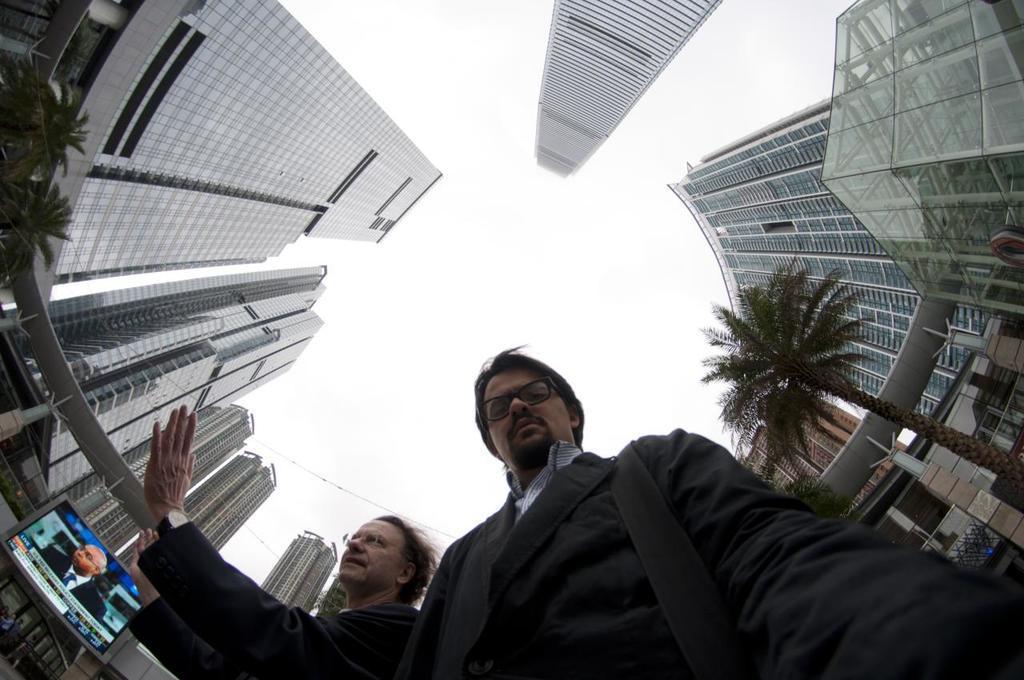Describe this image in one or two sentences. There are two people. We can see trees, screen, buildings and sky. 